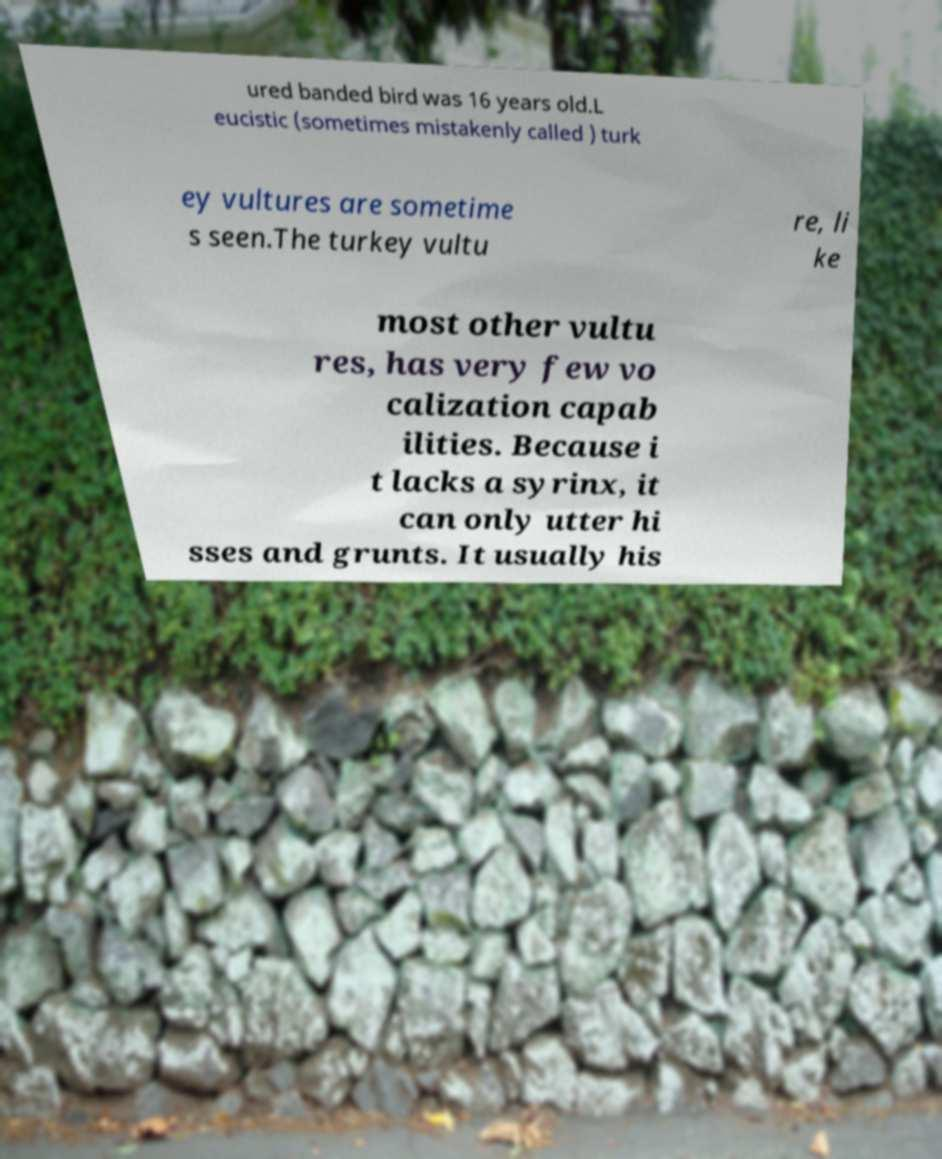Can you accurately transcribe the text from the provided image for me? ured banded bird was 16 years old.L eucistic (sometimes mistakenly called ) turk ey vultures are sometime s seen.The turkey vultu re, li ke most other vultu res, has very few vo calization capab ilities. Because i t lacks a syrinx, it can only utter hi sses and grunts. It usually his 